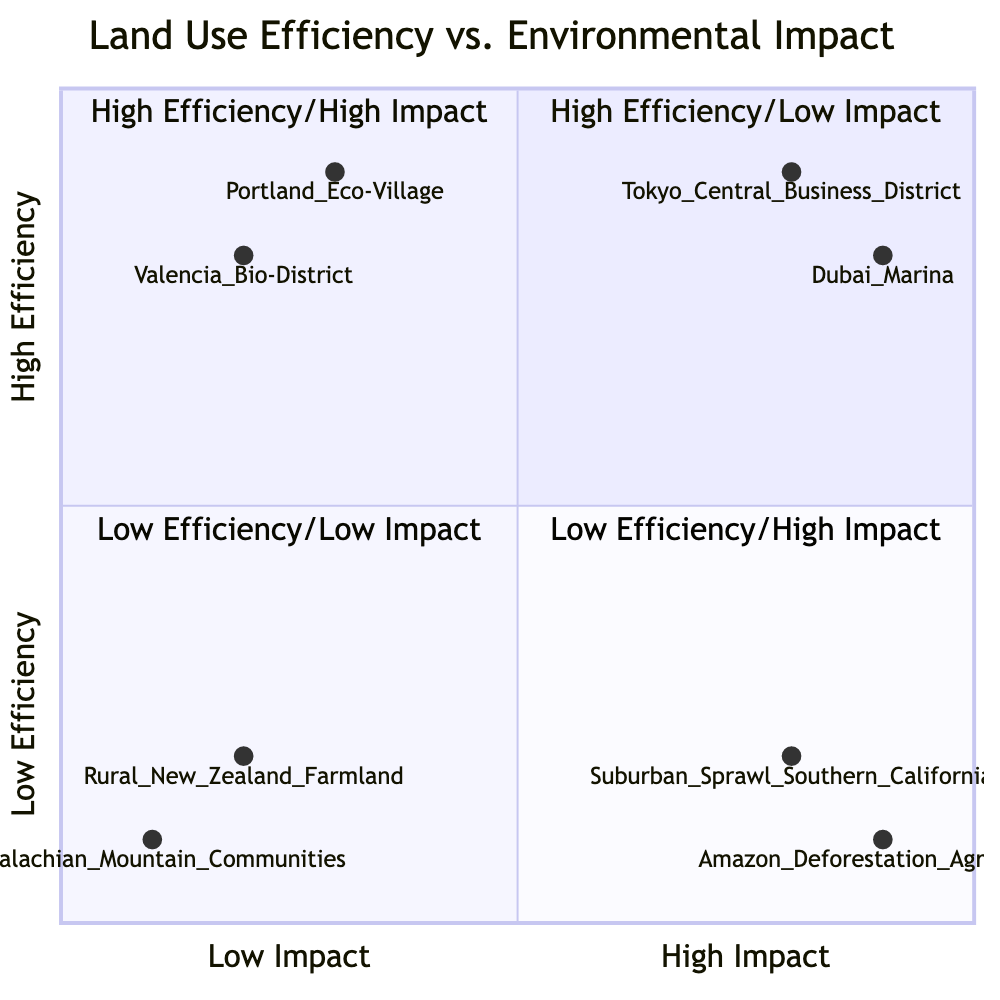What are two examples in the High Efficiency/Low Impact quadrant? The examples in this quadrant are Valencia Bio-District and Portland Eco-Village. Both projects focus on sustainable practices that minimize environmental impact while maintaining high efficiency in land use.
Answer: Valencia Bio-District, Portland Eco-Village How many total examples are there in the Low Efficiency/High Impact quadrant? There are two examples in the Low Efficiency/High Impact quadrant: Suburban Sprawl in Southern California and Amazon Deforestation for Agriculture. This is simply counted directly from the information provided.
Answer: 2 Which quadrant has the highest efficiency but also the highest environmental impact? The High Efficiency/High Impact quadrant includes Tokyo Central Business District and Dubai Marina, which are known for high efficiency in space use but also for significant environmental costs.
Answer: High Efficiency/High Impact List the low efficiency examples in the quadrants. The examples of low efficiency are Rural New Zealand Farmland and Appalachian Mountain Communities, as categorized in the Low Efficiency/Low Impact quadrant.
Answer: Rural New Zealand Farmland, Appalachian Mountain Communities What is the environmental impact level of the Amazon Deforestation for Agriculture? The Amazon Deforestation for Agriculture is characterized by high environmental impact as it leads to significant long-term damage, placing it in the Low Efficiency/High Impact quadrant.
Answer: High Impact Identify which quadrant contains the Portland Eco-Village. The Portland Eco-Village is located in the High Efficiency/Low Impact quadrant, as it emphasizes effective land use while ensuring minimal environmental harm.
Answer: High Efficiency/Low Impact Which example has the highest efficiency within the High Efficiency/High Impact quadrant? Within the High Efficiency/High Impact quadrant, Dubai Marina exhibits the highest efficiency level due to its intense residential and commercial development.
Answer: Dubai Marina What is the key characteristic of the Rural New Zealand Farmland? Rural New Zealand Farmland is characterized by low efficiency and low environmental impact, showcasing extensive land use with basic agricultural practices.
Answer: Low efficiency, low impact How does the environmental impact of the Suburban Sprawl in Southern California compare to rural examples? Suburban Sprawl in Southern California has a high environmental impact due to low-density housing and car reliance, contrasting sharply with rural examples which have minimal impact.
Answer: High environmental impact 